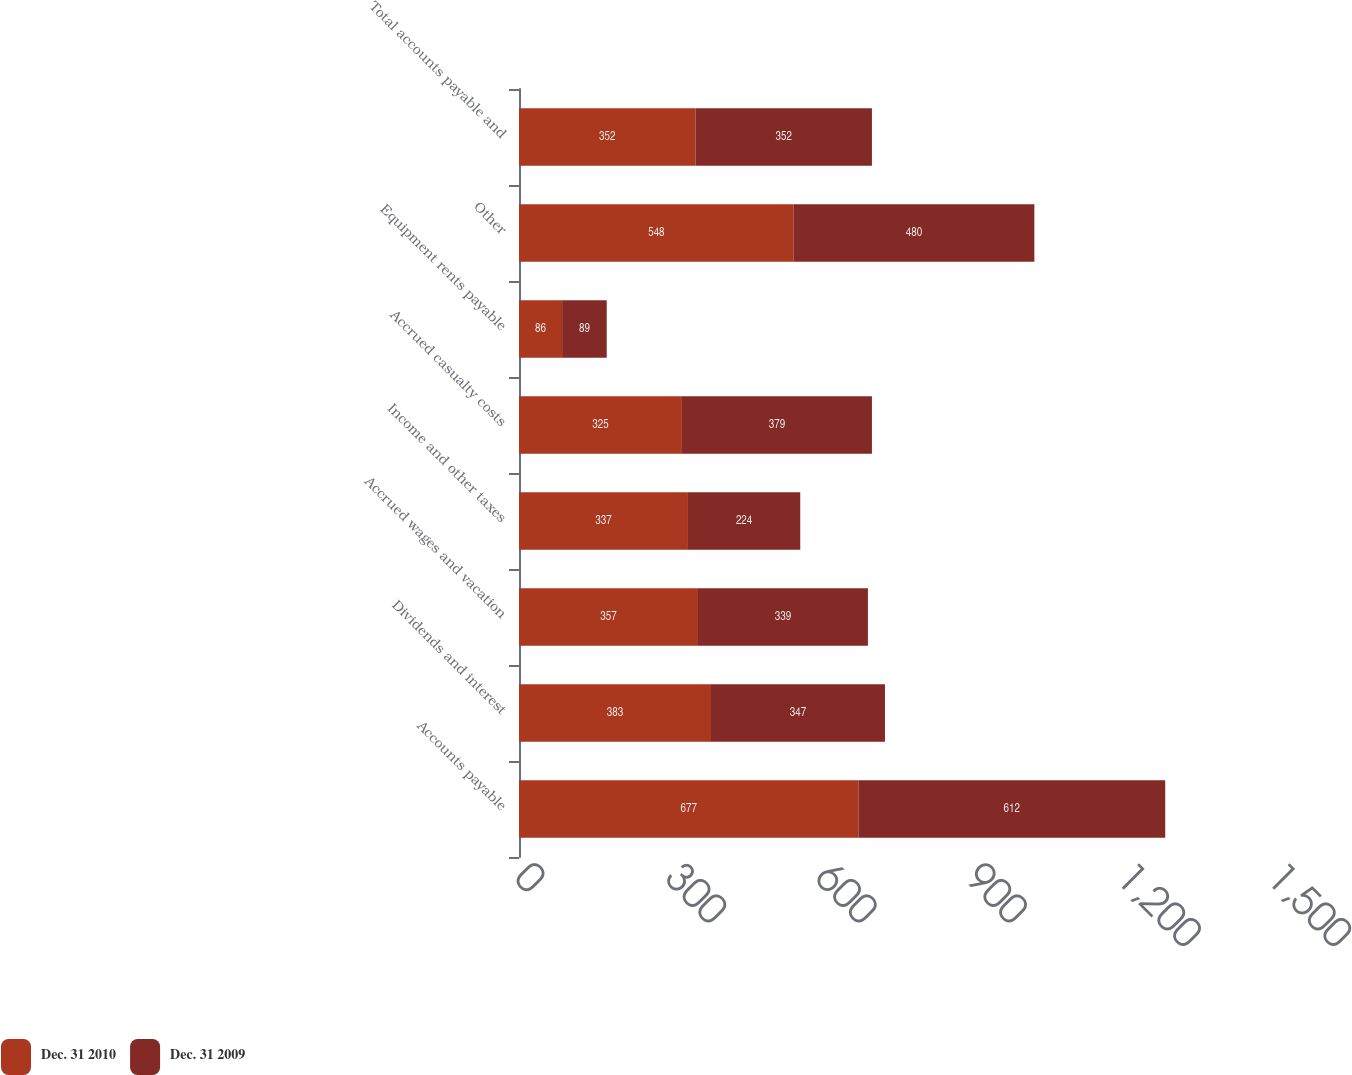<chart> <loc_0><loc_0><loc_500><loc_500><stacked_bar_chart><ecel><fcel>Accounts payable<fcel>Dividends and interest<fcel>Accrued wages and vacation<fcel>Income and other taxes<fcel>Accrued casualty costs<fcel>Equipment rents payable<fcel>Other<fcel>Total accounts payable and<nl><fcel>Dec. 31 2010<fcel>677<fcel>383<fcel>357<fcel>337<fcel>325<fcel>86<fcel>548<fcel>352<nl><fcel>Dec. 31 2009<fcel>612<fcel>347<fcel>339<fcel>224<fcel>379<fcel>89<fcel>480<fcel>352<nl></chart> 